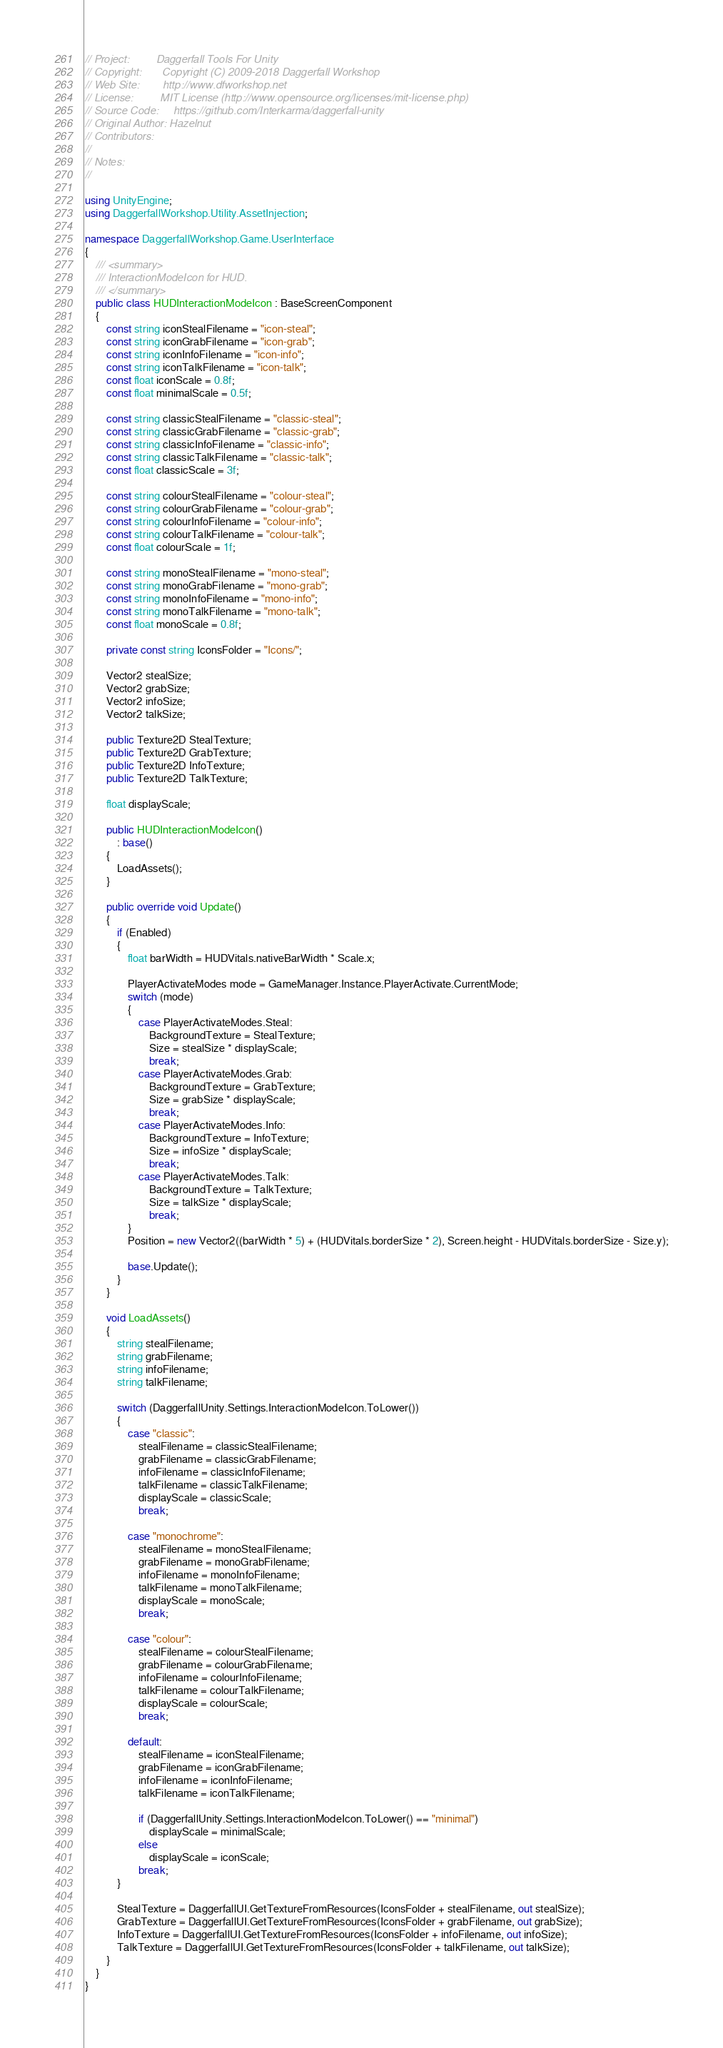<code> <loc_0><loc_0><loc_500><loc_500><_C#_>// Project:         Daggerfall Tools For Unity
// Copyright:       Copyright (C) 2009-2018 Daggerfall Workshop
// Web Site:        http://www.dfworkshop.net
// License:         MIT License (http://www.opensource.org/licenses/mit-license.php)
// Source Code:     https://github.com/Interkarma/daggerfall-unity
// Original Author: Hazelnut
// Contributors:    
// 
// Notes:
//

using UnityEngine;
using DaggerfallWorkshop.Utility.AssetInjection;
 
namespace DaggerfallWorkshop.Game.UserInterface
{
    /// <summary>
    /// InteractionModeIcon for HUD.
    /// </summary>
    public class HUDInteractionModeIcon : BaseScreenComponent
    {
        const string iconStealFilename = "icon-steal";
        const string iconGrabFilename = "icon-grab";
        const string iconInfoFilename = "icon-info";
        const string iconTalkFilename = "icon-talk";
        const float iconScale = 0.8f;
        const float minimalScale = 0.5f;

        const string classicStealFilename = "classic-steal";
        const string classicGrabFilename = "classic-grab";
        const string classicInfoFilename = "classic-info";
        const string classicTalkFilename = "classic-talk";
        const float classicScale = 3f;

        const string colourStealFilename = "colour-steal";
        const string colourGrabFilename = "colour-grab";
        const string colourInfoFilename = "colour-info";
        const string colourTalkFilename = "colour-talk";
        const float colourScale = 1f;

        const string monoStealFilename = "mono-steal";
        const string monoGrabFilename = "mono-grab";
        const string monoInfoFilename = "mono-info";
        const string monoTalkFilename = "mono-talk";
        const float monoScale = 0.8f;

        private const string IconsFolder = "Icons/";

        Vector2 stealSize;
        Vector2 grabSize;
        Vector2 infoSize;
        Vector2 talkSize;

        public Texture2D StealTexture;
        public Texture2D GrabTexture;
        public Texture2D InfoTexture;
        public Texture2D TalkTexture;

        float displayScale;

        public HUDInteractionModeIcon()
            : base()
        {
            LoadAssets();
        }

        public override void Update()
        {
            if (Enabled)
            {
                float barWidth = HUDVitals.nativeBarWidth * Scale.x;

                PlayerActivateModes mode = GameManager.Instance.PlayerActivate.CurrentMode;
                switch (mode)
                {
                    case PlayerActivateModes.Steal:
                        BackgroundTexture = StealTexture;
                        Size = stealSize * displayScale;
                        break;
                    case PlayerActivateModes.Grab:
                        BackgroundTexture = GrabTexture;
                        Size = grabSize * displayScale;
                        break;
                    case PlayerActivateModes.Info:
                        BackgroundTexture = InfoTexture;
                        Size = infoSize * displayScale;
                        break;
                    case PlayerActivateModes.Talk:
                        BackgroundTexture = TalkTexture;
                        Size = talkSize * displayScale;
                        break;
                }
                Position = new Vector2((barWidth * 5) + (HUDVitals.borderSize * 2), Screen.height - HUDVitals.borderSize - Size.y);

                base.Update();
            }
        }

        void LoadAssets()
        {
            string stealFilename;
            string grabFilename;
            string infoFilename;
            string talkFilename;

            switch (DaggerfallUnity.Settings.InteractionModeIcon.ToLower())
            {
                case "classic":
                    stealFilename = classicStealFilename;
                    grabFilename = classicGrabFilename;
                    infoFilename = classicInfoFilename;
                    talkFilename = classicTalkFilename;
                    displayScale = classicScale;
                    break;

                case "monochrome":
                    stealFilename = monoStealFilename;
                    grabFilename = monoGrabFilename;
                    infoFilename = monoInfoFilename;
                    talkFilename = monoTalkFilename;
                    displayScale = monoScale;
                    break;

                case "colour":
                    stealFilename = colourStealFilename;
                    grabFilename = colourGrabFilename;
                    infoFilename = colourInfoFilename;
                    talkFilename = colourTalkFilename;
                    displayScale = colourScale;
                    break;

                default:
                    stealFilename = iconStealFilename;
                    grabFilename = iconGrabFilename;
                    infoFilename = iconInfoFilename;
                    talkFilename = iconTalkFilename;

                    if (DaggerfallUnity.Settings.InteractionModeIcon.ToLower() == "minimal")
                        displayScale = minimalScale;
                    else
                        displayScale = iconScale;
                    break;
            }

            StealTexture = DaggerfallUI.GetTextureFromResources(IconsFolder + stealFilename, out stealSize);
            GrabTexture = DaggerfallUI.GetTextureFromResources(IconsFolder + grabFilename, out grabSize);
            InfoTexture = DaggerfallUI.GetTextureFromResources(IconsFolder + infoFilename, out infoSize);
            TalkTexture = DaggerfallUI.GetTextureFromResources(IconsFolder + talkFilename, out talkSize);
        }
    }
}</code> 